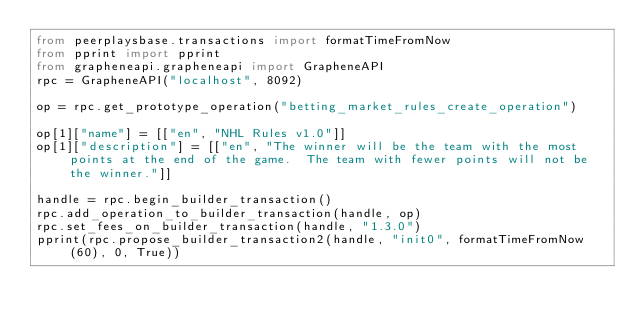Convert code to text. <code><loc_0><loc_0><loc_500><loc_500><_Python_>from peerplaysbase.transactions import formatTimeFromNow
from pprint import pprint
from grapheneapi.grapheneapi import GrapheneAPI
rpc = GrapheneAPI("localhost", 8092)

op = rpc.get_prototype_operation("betting_market_rules_create_operation")

op[1]["name"] = [["en", "NHL Rules v1.0"]]
op[1]["description"] = [["en", "The winner will be the team with the most points at the end of the game.  The team with fewer points will not be the winner."]]

handle = rpc.begin_builder_transaction()
rpc.add_operation_to_builder_transaction(handle, op)
rpc.set_fees_on_builder_transaction(handle, "1.3.0")
pprint(rpc.propose_builder_transaction2(handle, "init0", formatTimeFromNow(60), 0, True))
</code> 